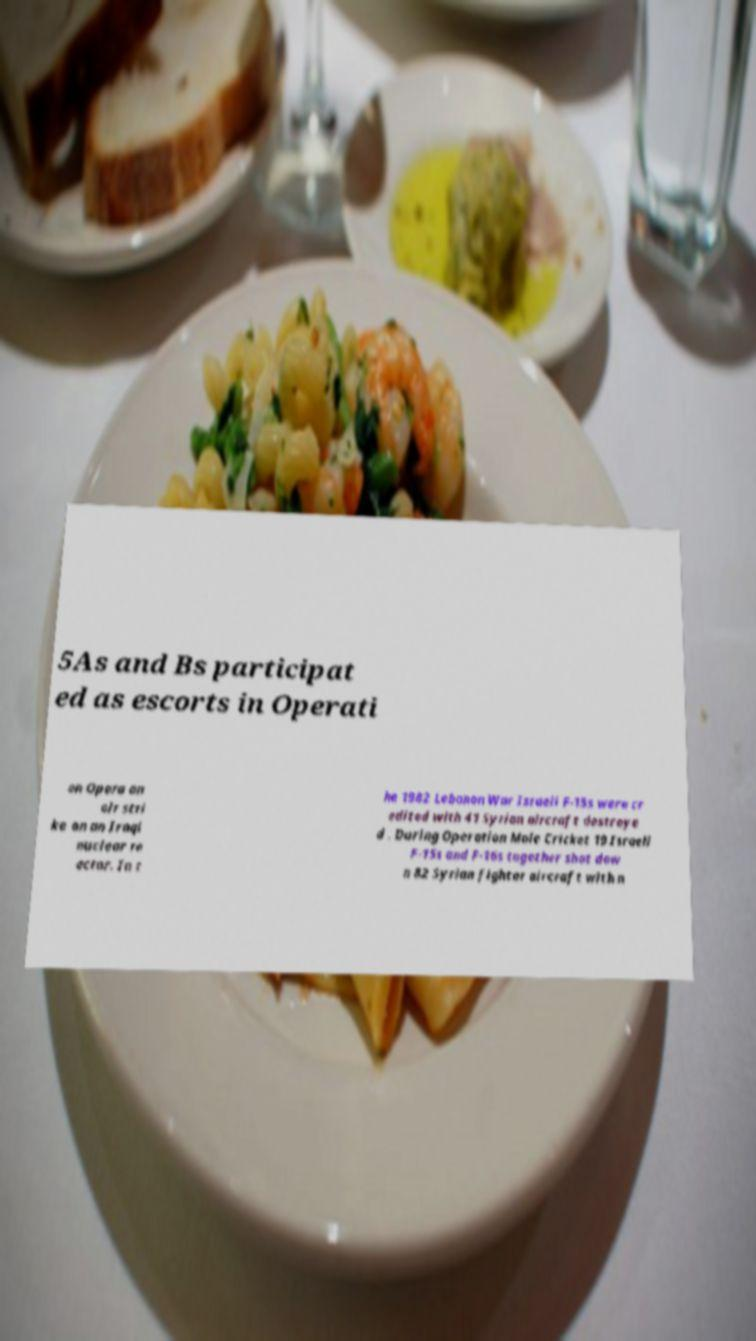Can you accurately transcribe the text from the provided image for me? 5As and Bs participat ed as escorts in Operati on Opera an air stri ke on an Iraqi nuclear re actor. In t he 1982 Lebanon War Israeli F-15s were cr edited with 41 Syrian aircraft destroye d . During Operation Mole Cricket 19 Israeli F-15s and F-16s together shot dow n 82 Syrian fighter aircraft with n 